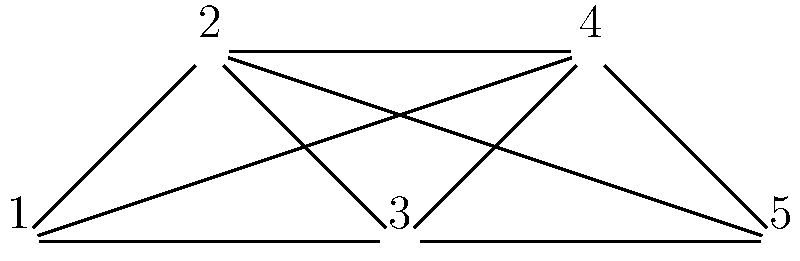As a sports fan organizing a stadium seating arrangement for a major event, you need to separate rival fan groups. The graph represents five fan groups, where connected groups are rivals. What is the minimum number of different seating sections needed to ensure no rival groups are seated together? To solve this problem, we'll use graph coloring:

1. Each vertex represents a fan group.
2. Each edge represents rivalry between groups.
3. Colors represent different seating sections.

Step-by-step solution:
1. Start with vertex 1. Assign it color A.
2. Vertex 2 is connected to 1, so it needs a new color, B.
3. Vertex 3 is connected to both 1 and 2, so it needs a new color, C.
4. Vertex 4 is connected to 1, 2, and 3. It can use color A as it's not connected to any vertex with color A.
5. Vertex 5 is connected to all other vertices, so it needs a new color, D.

The chromatic number of this graph is 4, meaning we need at least 4 different colors (seating sections) to properly separate all rival groups.

This problem relates to the Four Color Theorem in graph theory, which states that any planar graph can be colored using at most four colors. While our graph is not necessarily planar, it demonstrates a practical application of graph coloring in organizing events, which would appeal to a sports and entertainment enthusiast.
Answer: 4 seating sections 